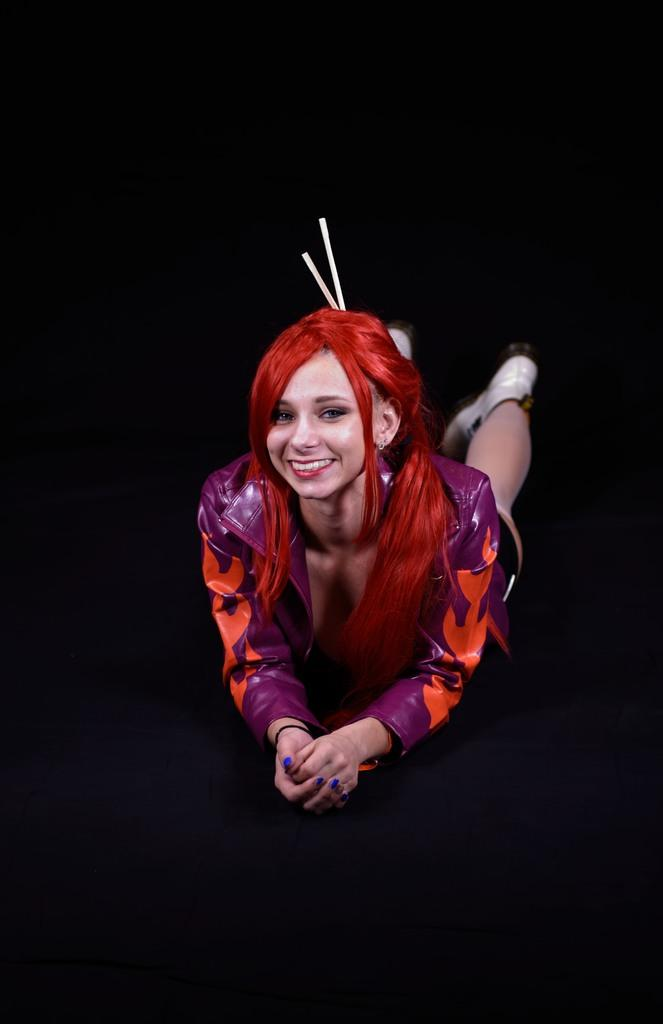Who is the main subject in the image? There is a woman in the image. What is the woman doing in the image? The woman is lying on a surface. What color is the background of the image? The background of the image is black. What note is the woman playing on her guitar in the image? There is no guitar present in the image, and the woman is lying down rather than playing an instrument. 